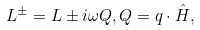<formula> <loc_0><loc_0><loc_500><loc_500>L ^ { \pm } = L \pm i \omega Q , Q = q \cdot \hat { H } ,</formula> 